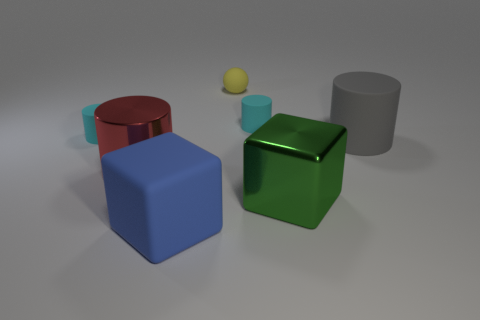Subtract all large gray cylinders. How many cylinders are left? 3 Add 1 large green metallic things. How many objects exist? 8 Subtract all cyan cubes. Subtract all cyan balls. How many cubes are left? 2 Subtract all brown blocks. How many gray cylinders are left? 1 Subtract all tiny matte things. Subtract all big green shiny cubes. How many objects are left? 3 Add 4 big green shiny things. How many big green shiny things are left? 5 Add 3 tiny yellow objects. How many tiny yellow objects exist? 4 Subtract all blue cubes. How many cubes are left? 1 Subtract 0 yellow cubes. How many objects are left? 7 Subtract all cylinders. How many objects are left? 3 